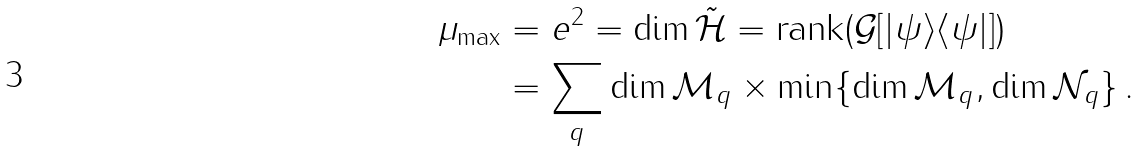<formula> <loc_0><loc_0><loc_500><loc_500>\mu _ { \max } & = \| e \| ^ { 2 } = \dim \tilde { \mathcal { H } } = \text {rank} ( \mathcal { G } [ | \psi \rangle \langle \psi | ] ) \\ & = \sum _ { q } \dim \mathcal { M } _ { q } \times \min \{ \dim \mathcal { M } _ { q } , \dim \mathcal { N } _ { q } \} \, .</formula> 